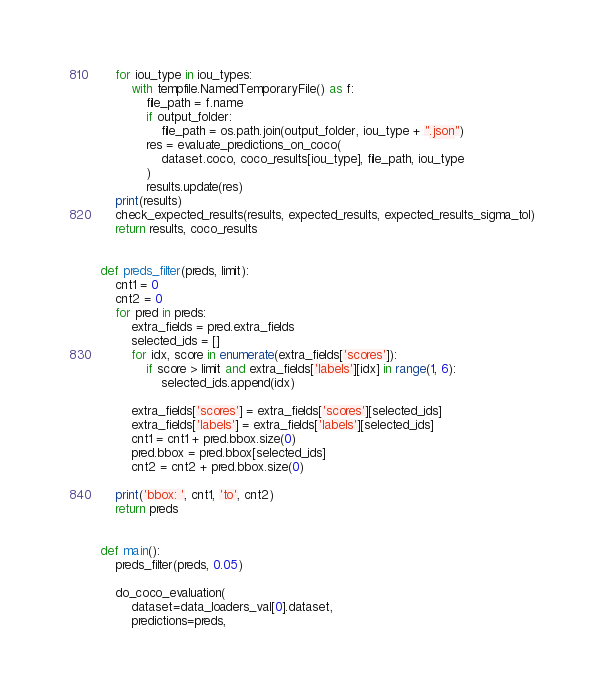Convert code to text. <code><loc_0><loc_0><loc_500><loc_500><_Python_>    for iou_type in iou_types:
        with tempfile.NamedTemporaryFile() as f:
            file_path = f.name
            if output_folder:
                file_path = os.path.join(output_folder, iou_type + ".json")
            res = evaluate_predictions_on_coco(
                dataset.coco, coco_results[iou_type], file_path, iou_type
            )
            results.update(res)
    print(results)
    check_expected_results(results, expected_results, expected_results_sigma_tol)
    return results, coco_results


def preds_filter(preds, limit):
    cnt1 = 0
    cnt2 = 0
    for pred in preds:
        extra_fields = pred.extra_fields
        selected_ids = []
        for idx, score in enumerate(extra_fields['scores']):
            if score > limit and extra_fields['labels'][idx] in range(1, 6):
                selected_ids.append(idx)

        extra_fields['scores'] = extra_fields['scores'][selected_ids]
        extra_fields['labels'] = extra_fields['labels'][selected_ids]
        cnt1 = cnt1 + pred.bbox.size(0)
        pred.bbox = pred.bbox[selected_ids]
        cnt2 = cnt2 + pred.bbox.size(0)

    print('bbox: ', cnt1, 'to', cnt2)
    return preds


def main():
    preds_filter(preds, 0.05)

    do_coco_evaluation(
        dataset=data_loaders_val[0].dataset,
        predictions=preds,</code> 